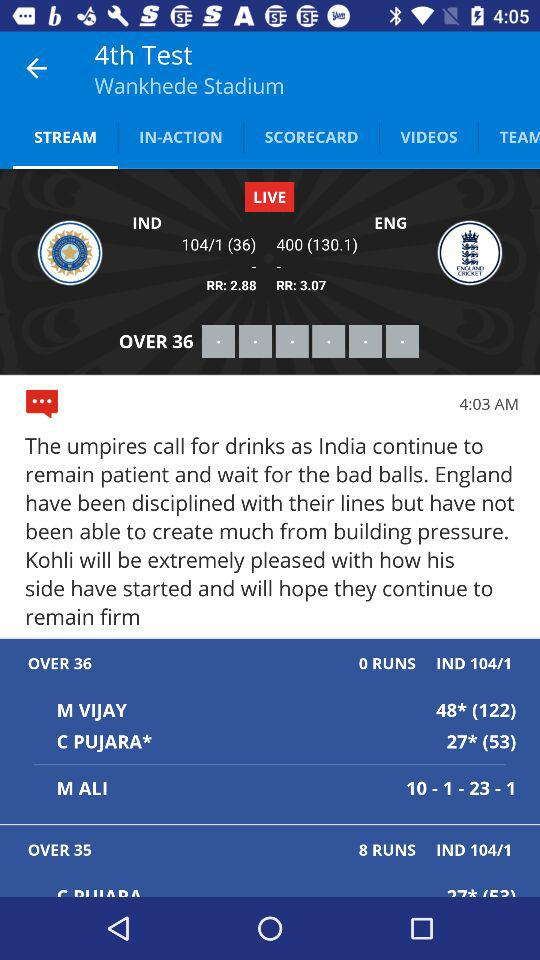How many wickets has "India" lost for 104 runs? "India" has lost 1 wicket for 104 runs. 